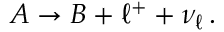Convert formula to latex. <formula><loc_0><loc_0><loc_500><loc_500>A \to B + \ell ^ { + } + \nu _ { \ell } \, .</formula> 